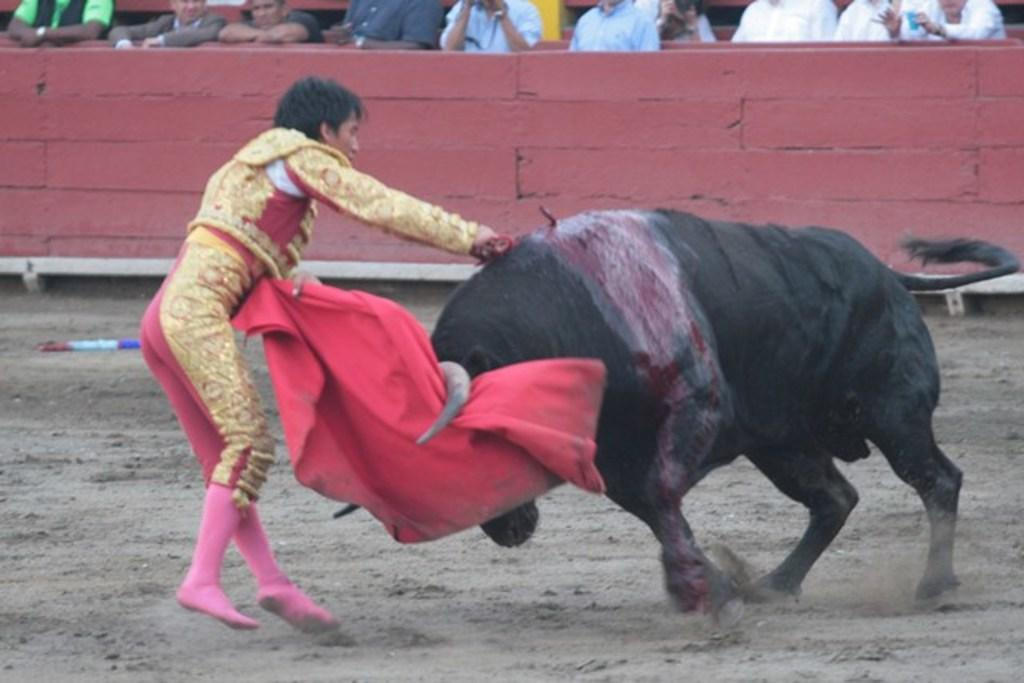Who is the main subject in the image? The main subject in the image is a man. What is the man holding in the image? The man is holding a red cloth in the image. What animal is present in the image? There is a bull in the image. Where is the bull positioned in relation to the man? The bull is in front of the man in the image. What is visible behind the bull? There is a wall behind the bull in the image. Are there any other people in the image? Yes, there are people standing near the wall in the image. What type of paper is being used to create the wilderness scene in the image? There is no paper or wilderness scene present in the image; it features a man, a bull, and other people. 